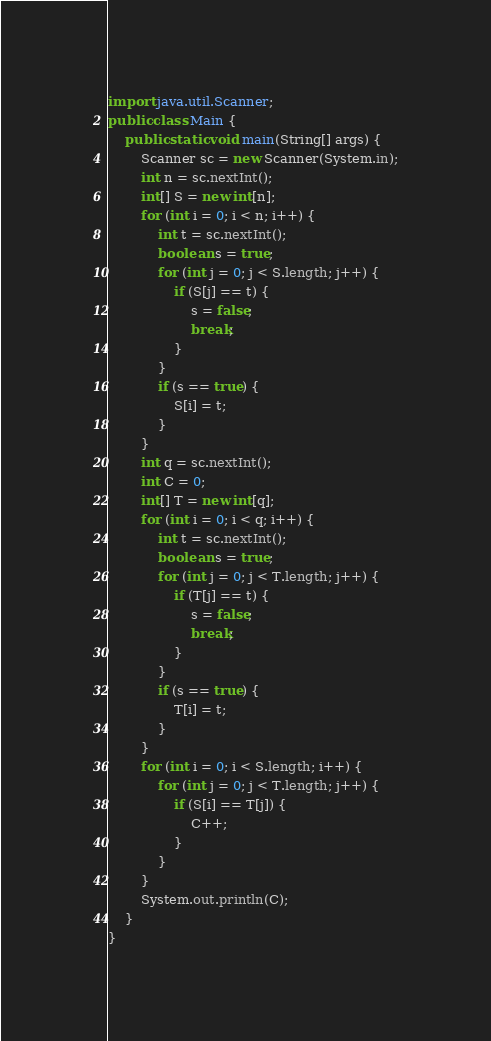Convert code to text. <code><loc_0><loc_0><loc_500><loc_500><_Java_>import java.util.Scanner;
public class Main {
    public static void main(String[] args) {
        Scanner sc = new Scanner(System.in);
        int n = sc.nextInt();
        int[] S = new int[n];
        for (int i = 0; i < n; i++) {
            int t = sc.nextInt();
            boolean s = true;
            for (int j = 0; j < S.length; j++) {
                if (S[j] == t) {
                    s = false;
                    break;
                }
            }
            if (s == true) {
                S[i] = t;
            }
        }
        int q = sc.nextInt();
        int C = 0;
        int[] T = new int[q];
        for (int i = 0; i < q; i++) {
            int t = sc.nextInt();
            boolean s = true;
            for (int j = 0; j < T.length; j++) {
                if (T[j] == t) {
                    s = false;
                    break;
                }
            }
            if (s == true) {
                T[i] = t;
            }
        }
        for (int i = 0; i < S.length; i++) {
            for (int j = 0; j < T.length; j++) {
                if (S[i] == T[j]) {
                    C++;
                }
            }
        }
        System.out.println(C);
    }
}</code> 